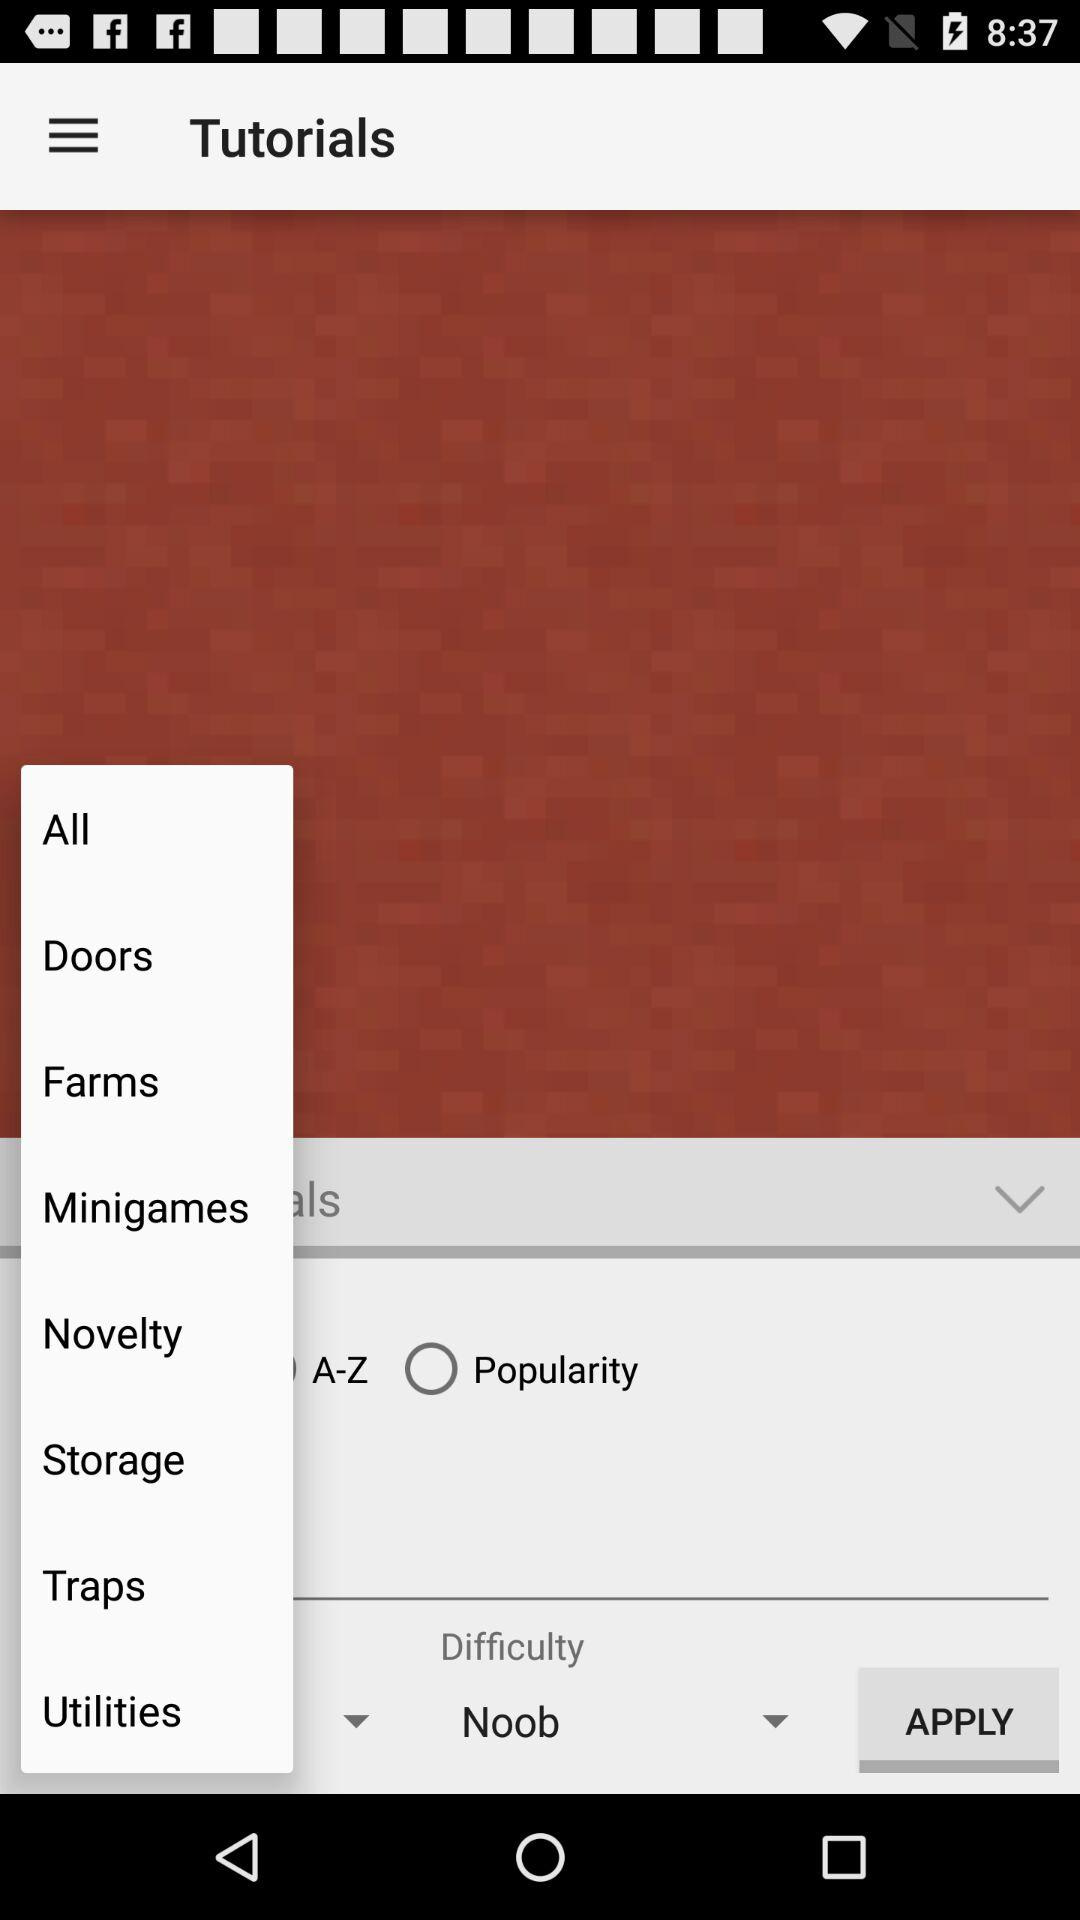What is the selected tab? The selected tab is "APPLY". 